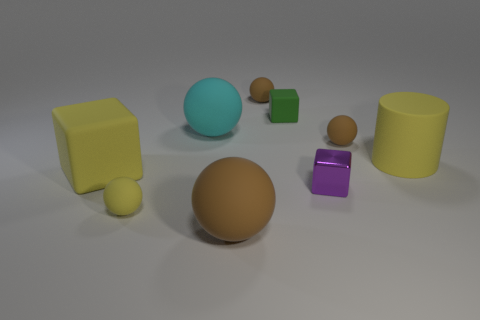Subtract all brown blocks. How many brown balls are left? 3 Subtract all big cyan matte balls. How many balls are left? 4 Add 1 brown spheres. How many objects exist? 10 Subtract all cyan spheres. How many spheres are left? 4 Subtract all red spheres. Subtract all yellow cylinders. How many spheres are left? 5 Subtract all cylinders. How many objects are left? 8 Add 2 metallic blocks. How many metallic blocks are left? 3 Add 6 small brown matte balls. How many small brown matte balls exist? 8 Subtract 1 green cubes. How many objects are left? 8 Subtract all green objects. Subtract all tiny objects. How many objects are left? 3 